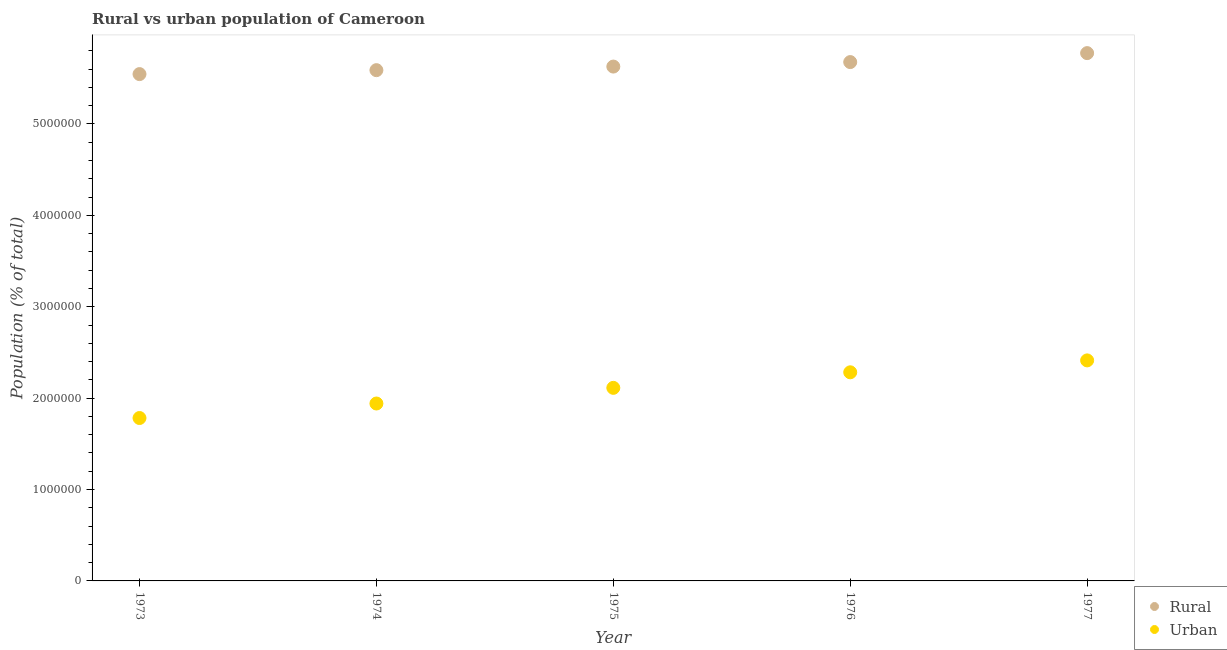What is the urban population density in 1974?
Offer a very short reply. 1.94e+06. Across all years, what is the maximum rural population density?
Provide a short and direct response. 5.77e+06. Across all years, what is the minimum rural population density?
Keep it short and to the point. 5.55e+06. In which year was the rural population density minimum?
Give a very brief answer. 1973. What is the total rural population density in the graph?
Your response must be concise. 2.82e+07. What is the difference between the rural population density in 1974 and that in 1977?
Make the answer very short. -1.86e+05. What is the difference between the urban population density in 1976 and the rural population density in 1977?
Keep it short and to the point. -3.49e+06. What is the average rural population density per year?
Keep it short and to the point. 5.64e+06. In the year 1977, what is the difference between the rural population density and urban population density?
Your answer should be compact. 3.36e+06. What is the ratio of the urban population density in 1973 to that in 1975?
Ensure brevity in your answer.  0.84. Is the difference between the rural population density in 1974 and 1975 greater than the difference between the urban population density in 1974 and 1975?
Your response must be concise. Yes. What is the difference between the highest and the second highest urban population density?
Offer a terse response. 1.30e+05. What is the difference between the highest and the lowest urban population density?
Provide a short and direct response. 6.30e+05. In how many years, is the urban population density greater than the average urban population density taken over all years?
Give a very brief answer. 3. Is the sum of the rural population density in 1973 and 1975 greater than the maximum urban population density across all years?
Provide a succinct answer. Yes. Are the values on the major ticks of Y-axis written in scientific E-notation?
Give a very brief answer. No. Does the graph contain any zero values?
Provide a succinct answer. No. How many legend labels are there?
Your response must be concise. 2. How are the legend labels stacked?
Your answer should be very brief. Vertical. What is the title of the graph?
Keep it short and to the point. Rural vs urban population of Cameroon. What is the label or title of the X-axis?
Your answer should be very brief. Year. What is the label or title of the Y-axis?
Your answer should be very brief. Population (% of total). What is the Population (% of total) in Rural in 1973?
Offer a very short reply. 5.55e+06. What is the Population (% of total) of Urban in 1973?
Make the answer very short. 1.78e+06. What is the Population (% of total) in Rural in 1974?
Your answer should be compact. 5.59e+06. What is the Population (% of total) of Urban in 1974?
Your answer should be very brief. 1.94e+06. What is the Population (% of total) in Rural in 1975?
Your response must be concise. 5.63e+06. What is the Population (% of total) of Urban in 1975?
Your answer should be very brief. 2.11e+06. What is the Population (% of total) in Rural in 1976?
Offer a terse response. 5.68e+06. What is the Population (% of total) of Urban in 1976?
Offer a very short reply. 2.28e+06. What is the Population (% of total) of Rural in 1977?
Make the answer very short. 5.77e+06. What is the Population (% of total) in Urban in 1977?
Provide a short and direct response. 2.41e+06. Across all years, what is the maximum Population (% of total) of Rural?
Keep it short and to the point. 5.77e+06. Across all years, what is the maximum Population (% of total) of Urban?
Ensure brevity in your answer.  2.41e+06. Across all years, what is the minimum Population (% of total) in Rural?
Offer a very short reply. 5.55e+06. Across all years, what is the minimum Population (% of total) in Urban?
Provide a short and direct response. 1.78e+06. What is the total Population (% of total) of Rural in the graph?
Your answer should be very brief. 2.82e+07. What is the total Population (% of total) of Urban in the graph?
Your response must be concise. 1.05e+07. What is the difference between the Population (% of total) of Rural in 1973 and that in 1974?
Your answer should be compact. -4.31e+04. What is the difference between the Population (% of total) of Urban in 1973 and that in 1974?
Your answer should be very brief. -1.59e+05. What is the difference between the Population (% of total) in Rural in 1973 and that in 1975?
Make the answer very short. -8.23e+04. What is the difference between the Population (% of total) in Urban in 1973 and that in 1975?
Your answer should be very brief. -3.30e+05. What is the difference between the Population (% of total) in Rural in 1973 and that in 1976?
Make the answer very short. -1.31e+05. What is the difference between the Population (% of total) of Urban in 1973 and that in 1976?
Give a very brief answer. -5.00e+05. What is the difference between the Population (% of total) of Rural in 1973 and that in 1977?
Your answer should be compact. -2.30e+05. What is the difference between the Population (% of total) in Urban in 1973 and that in 1977?
Provide a short and direct response. -6.30e+05. What is the difference between the Population (% of total) in Rural in 1974 and that in 1975?
Your answer should be very brief. -3.92e+04. What is the difference between the Population (% of total) of Urban in 1974 and that in 1975?
Keep it short and to the point. -1.71e+05. What is the difference between the Population (% of total) of Rural in 1974 and that in 1976?
Provide a short and direct response. -8.83e+04. What is the difference between the Population (% of total) of Urban in 1974 and that in 1976?
Provide a succinct answer. -3.41e+05. What is the difference between the Population (% of total) of Rural in 1974 and that in 1977?
Keep it short and to the point. -1.86e+05. What is the difference between the Population (% of total) of Urban in 1974 and that in 1977?
Give a very brief answer. -4.72e+05. What is the difference between the Population (% of total) in Rural in 1975 and that in 1976?
Provide a short and direct response. -4.91e+04. What is the difference between the Population (% of total) of Urban in 1975 and that in 1976?
Your answer should be compact. -1.70e+05. What is the difference between the Population (% of total) in Rural in 1975 and that in 1977?
Offer a terse response. -1.47e+05. What is the difference between the Population (% of total) in Urban in 1975 and that in 1977?
Offer a very short reply. -3.00e+05. What is the difference between the Population (% of total) of Rural in 1976 and that in 1977?
Keep it short and to the point. -9.81e+04. What is the difference between the Population (% of total) of Urban in 1976 and that in 1977?
Make the answer very short. -1.30e+05. What is the difference between the Population (% of total) of Rural in 1973 and the Population (% of total) of Urban in 1974?
Offer a very short reply. 3.60e+06. What is the difference between the Population (% of total) of Rural in 1973 and the Population (% of total) of Urban in 1975?
Give a very brief answer. 3.43e+06. What is the difference between the Population (% of total) in Rural in 1973 and the Population (% of total) in Urban in 1976?
Your response must be concise. 3.26e+06. What is the difference between the Population (% of total) of Rural in 1973 and the Population (% of total) of Urban in 1977?
Offer a very short reply. 3.13e+06. What is the difference between the Population (% of total) in Rural in 1974 and the Population (% of total) in Urban in 1975?
Make the answer very short. 3.48e+06. What is the difference between the Population (% of total) of Rural in 1974 and the Population (% of total) of Urban in 1976?
Provide a succinct answer. 3.31e+06. What is the difference between the Population (% of total) in Rural in 1974 and the Population (% of total) in Urban in 1977?
Your answer should be compact. 3.18e+06. What is the difference between the Population (% of total) of Rural in 1975 and the Population (% of total) of Urban in 1976?
Your response must be concise. 3.35e+06. What is the difference between the Population (% of total) in Rural in 1975 and the Population (% of total) in Urban in 1977?
Offer a terse response. 3.21e+06. What is the difference between the Population (% of total) in Rural in 1976 and the Population (% of total) in Urban in 1977?
Make the answer very short. 3.26e+06. What is the average Population (% of total) of Rural per year?
Keep it short and to the point. 5.64e+06. What is the average Population (% of total) of Urban per year?
Provide a short and direct response. 2.11e+06. In the year 1973, what is the difference between the Population (% of total) of Rural and Population (% of total) of Urban?
Your answer should be compact. 3.76e+06. In the year 1974, what is the difference between the Population (% of total) of Rural and Population (% of total) of Urban?
Ensure brevity in your answer.  3.65e+06. In the year 1975, what is the difference between the Population (% of total) of Rural and Population (% of total) of Urban?
Keep it short and to the point. 3.52e+06. In the year 1976, what is the difference between the Population (% of total) of Rural and Population (% of total) of Urban?
Your answer should be very brief. 3.39e+06. In the year 1977, what is the difference between the Population (% of total) in Rural and Population (% of total) in Urban?
Make the answer very short. 3.36e+06. What is the ratio of the Population (% of total) in Urban in 1973 to that in 1974?
Offer a terse response. 0.92. What is the ratio of the Population (% of total) in Rural in 1973 to that in 1975?
Give a very brief answer. 0.99. What is the ratio of the Population (% of total) of Urban in 1973 to that in 1975?
Provide a short and direct response. 0.84. What is the ratio of the Population (% of total) in Rural in 1973 to that in 1976?
Provide a short and direct response. 0.98. What is the ratio of the Population (% of total) of Urban in 1973 to that in 1976?
Ensure brevity in your answer.  0.78. What is the ratio of the Population (% of total) in Rural in 1973 to that in 1977?
Your answer should be compact. 0.96. What is the ratio of the Population (% of total) in Urban in 1973 to that in 1977?
Offer a very short reply. 0.74. What is the ratio of the Population (% of total) in Urban in 1974 to that in 1975?
Provide a succinct answer. 0.92. What is the ratio of the Population (% of total) of Rural in 1974 to that in 1976?
Ensure brevity in your answer.  0.98. What is the ratio of the Population (% of total) in Urban in 1974 to that in 1976?
Offer a terse response. 0.85. What is the ratio of the Population (% of total) of Urban in 1974 to that in 1977?
Your response must be concise. 0.8. What is the ratio of the Population (% of total) in Rural in 1975 to that in 1976?
Give a very brief answer. 0.99. What is the ratio of the Population (% of total) in Urban in 1975 to that in 1976?
Your response must be concise. 0.93. What is the ratio of the Population (% of total) of Rural in 1975 to that in 1977?
Provide a succinct answer. 0.97. What is the ratio of the Population (% of total) in Urban in 1975 to that in 1977?
Ensure brevity in your answer.  0.88. What is the ratio of the Population (% of total) of Rural in 1976 to that in 1977?
Make the answer very short. 0.98. What is the ratio of the Population (% of total) of Urban in 1976 to that in 1977?
Your answer should be very brief. 0.95. What is the difference between the highest and the second highest Population (% of total) in Rural?
Your answer should be compact. 9.81e+04. What is the difference between the highest and the second highest Population (% of total) of Urban?
Give a very brief answer. 1.30e+05. What is the difference between the highest and the lowest Population (% of total) in Rural?
Make the answer very short. 2.30e+05. What is the difference between the highest and the lowest Population (% of total) in Urban?
Give a very brief answer. 6.30e+05. 